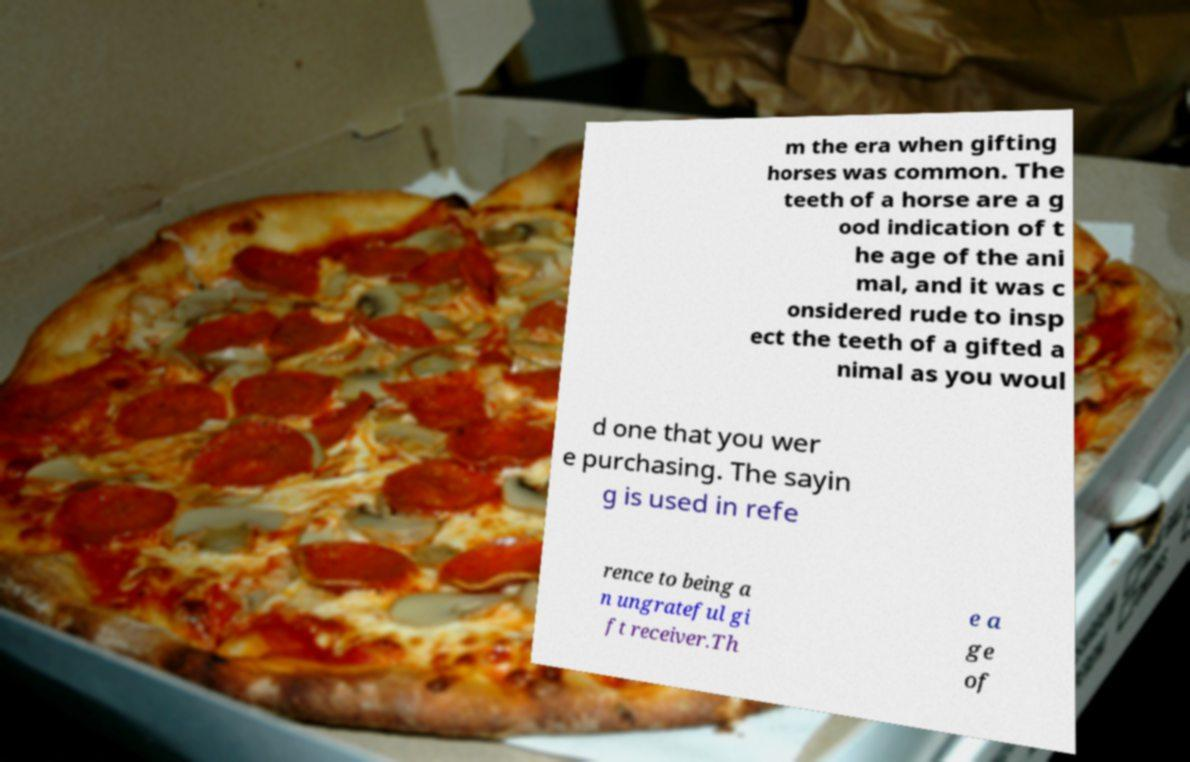What messages or text are displayed in this image? I need them in a readable, typed format. m the era when gifting horses was common. The teeth of a horse are a g ood indication of t he age of the ani mal, and it was c onsidered rude to insp ect the teeth of a gifted a nimal as you woul d one that you wer e purchasing. The sayin g is used in refe rence to being a n ungrateful gi ft receiver.Th e a ge of 